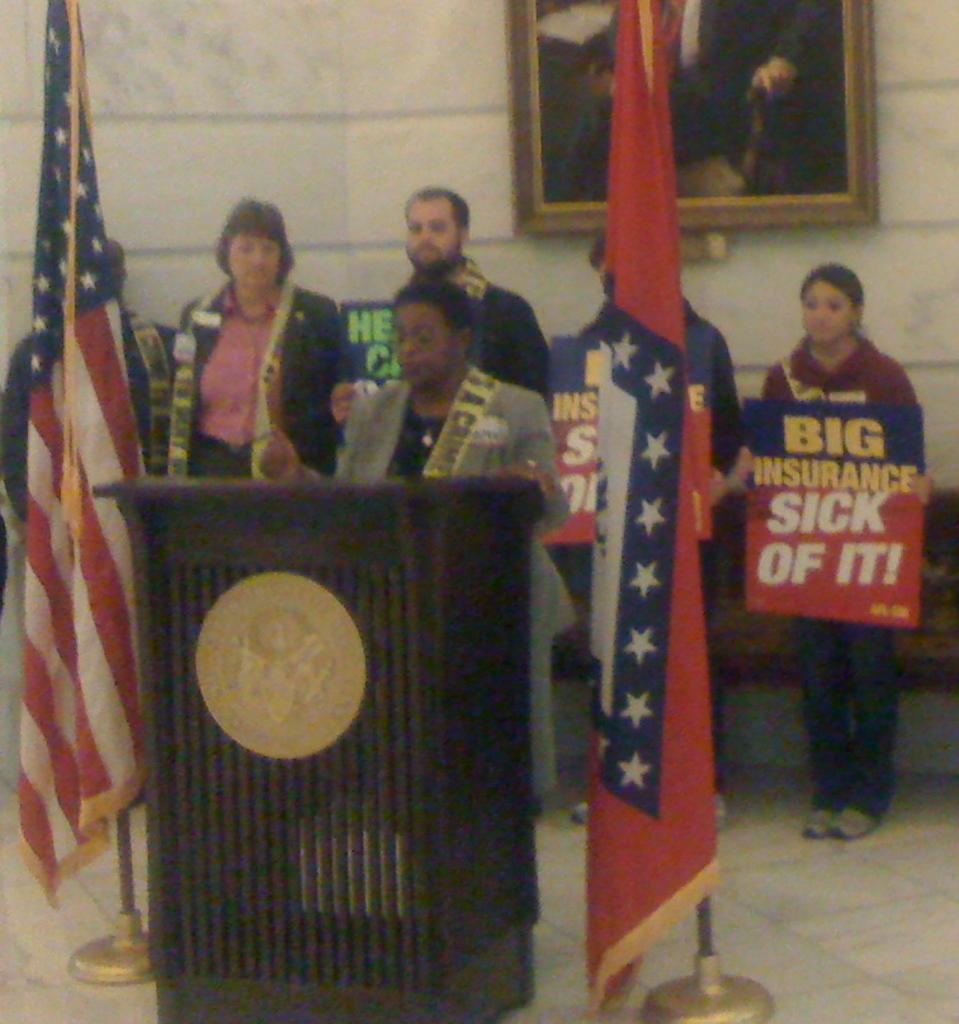<image>
Offer a succinct explanation of the picture presented. A black woman stands at a podium with an American flag next to her while a woman behind her holds a sign that reads "Big Insurance, Sick of It!" 